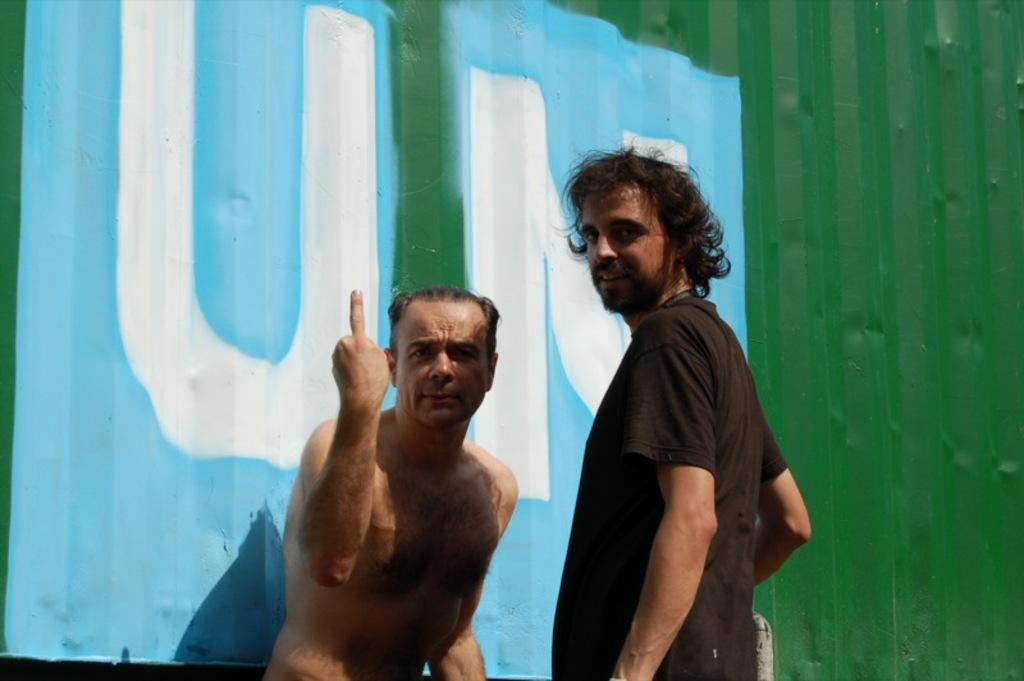How many people are present in the image? There are two persons in the image. What can be seen on the wall in the image? There is text on a wall in the image. How many kittens are playing on the ground in the image? There are no kittens present in the image. What type of wound can be seen on one of the persons in the image? There is no wound visible on either person in the image. 